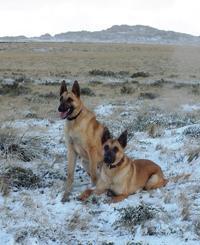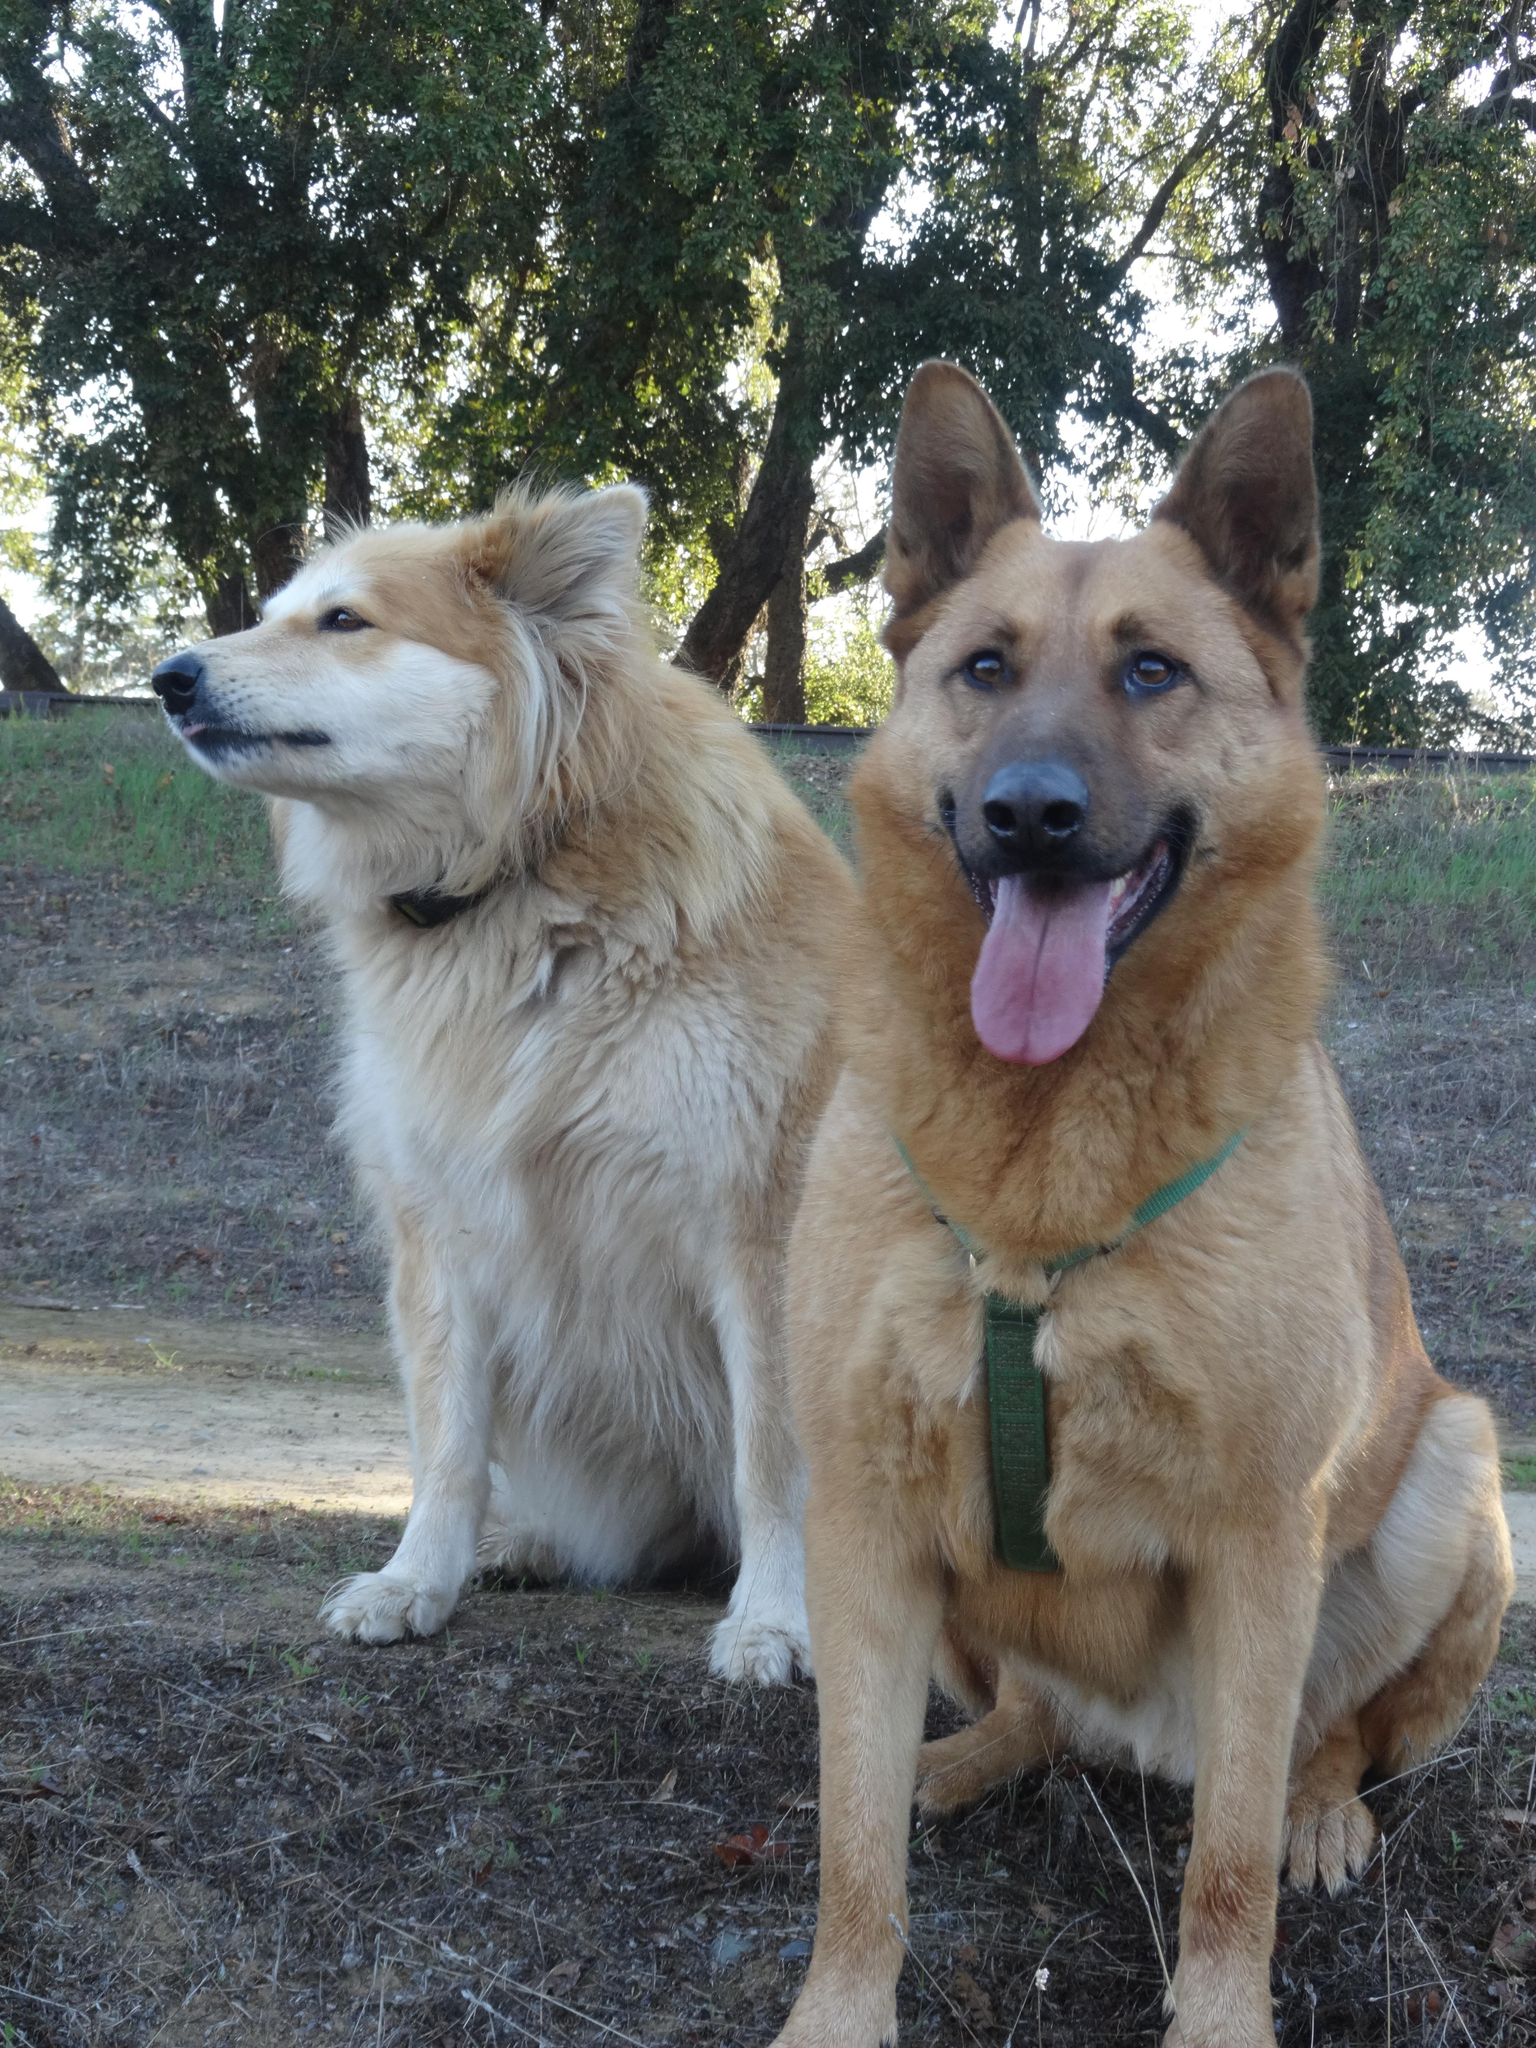The first image is the image on the left, the second image is the image on the right. Analyze the images presented: Is the assertion "There is one lone brown german shepherd sitting in the grass." valid? Answer yes or no. No. 